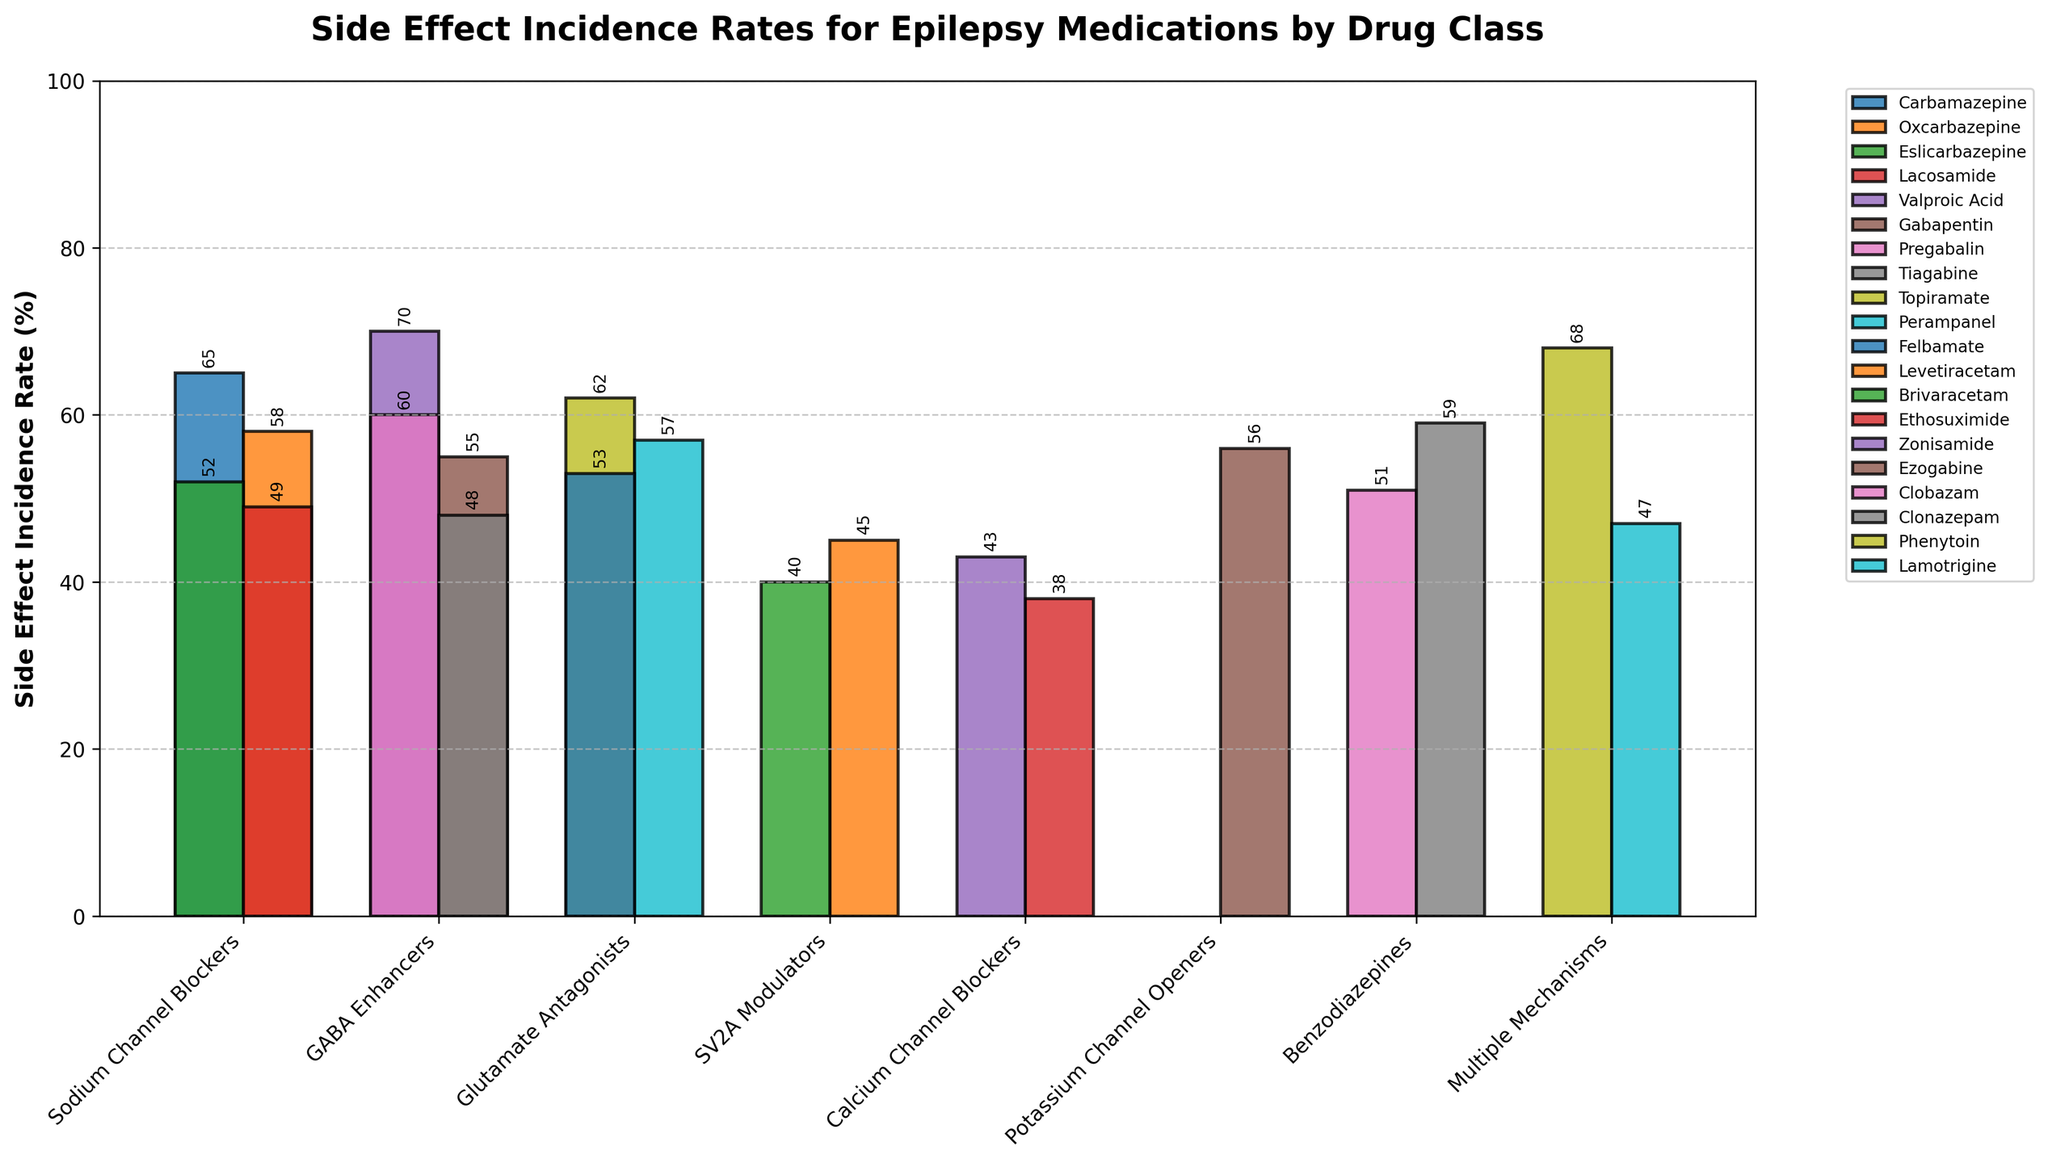Which drug has the highest side effect incidence rate in the GABA Enhancers class? Look for the highest bar in the GABA Enhancers group, which contains Valproic Acid, Gabapentin, Pregabalin, and Tiagabine. The highest bar is Valproic Acid with a rate of 70%.
Answer: Valproic Acid Which drug in the Sodium Channel Blockers class has a lower side effect incidence rate: Oxcarbazepine or Lacosamide? Compare the heights of the bars for Oxcarbazepine and Lacosamide within the Sodium Channel Blockers class. Oxcarbazepine has an incidence rate of 58%, while Lacosamide has 49%.
Answer: Lacosamide What is the average side effect incidence rate of the SV2A Modulators class? Add the incidence rates of Levetiracetam (45%) and Brivaracetam (40%) and divide by 2. (45 + 40) / 2 = 42.5%
Answer: 42.5% Are the rates for Ethosuximide and Zonisamide in the Calcium Channel Blockers class higher or lower than the rates for the medications in the Benzodiazepines class? Compare the bars of Ethosuximide (38%) and Zonisamide (43%) with Clobazam (51%) and Clonazepam (59%). All rates in Benzodiazepines are higher than those in Calcium Channel Blockers.
Answer: Lower What is the difference in side effect incidence rates between Phenytoin in the Multiple Mechanisms class and Clobazam in the Benzodiazepines class? Subtract the incidence rate of Clobazam (51%) from Phenytoin (68%). 68 - 51 = 17%
Answer: 17% Which class has the lowest side effect incidence rate when considering their lowest reported values? Identify the lowest bars in each class and compare them. Ethosuximide in Calcium Channel Blockers has the lowest incidence rate at 38%.
Answer: Calcium Channel Blockers What is the total incidence rate of all medications in the Glutamate Antagonists class? Sum the incidence rates of Topiramate (62%), Perampanel (57%), and Felbamate (53%). 62 + 57 + 53 = 172%
Answer: 172% Which class shows the greatest variation in side effect incidence rates among its medications? Calculate the range for each class by subtracting the smallest rate from the largest rate. Sodium Channel Blockers: 65 - 49 = 16; GABA Enhancers: 70 - 48 = 22; Glutamate Antagonists: 62 - 53 = 9; SV2A Modulators: 45 - 40 = 5; Calcium Channel Blockers: 43 - 38 = 5; Potassium Channel Openers: single drug; Benzodiazepines: 59 - 51 = 8; Multiple Mechanisms: 68 - 47 = 21. The GABA Enhancers class has the highest range of 22%.
Answer: GABA Enhancers Which drug has the second-highest incidence rate in the Multiple Mechanisms class? Identify the two drugs in the Multiple Mechanisms class: Phenytoin (68%) and Lamotrigine (47%). The second-highest rate is Lamotrigine with 47%.
Answer: Lamotrigine Is the side effect incidence rate of Pregabalin higher or lower than the average rate for the GABA Enhancers class? Calculate the average rate for the GABA Enhancers class (70 + 55 + 60 + 48) / 4 = 58.25%. Compare it with Pregabalin's rate of 60%, which is higher.
Answer: Higher 